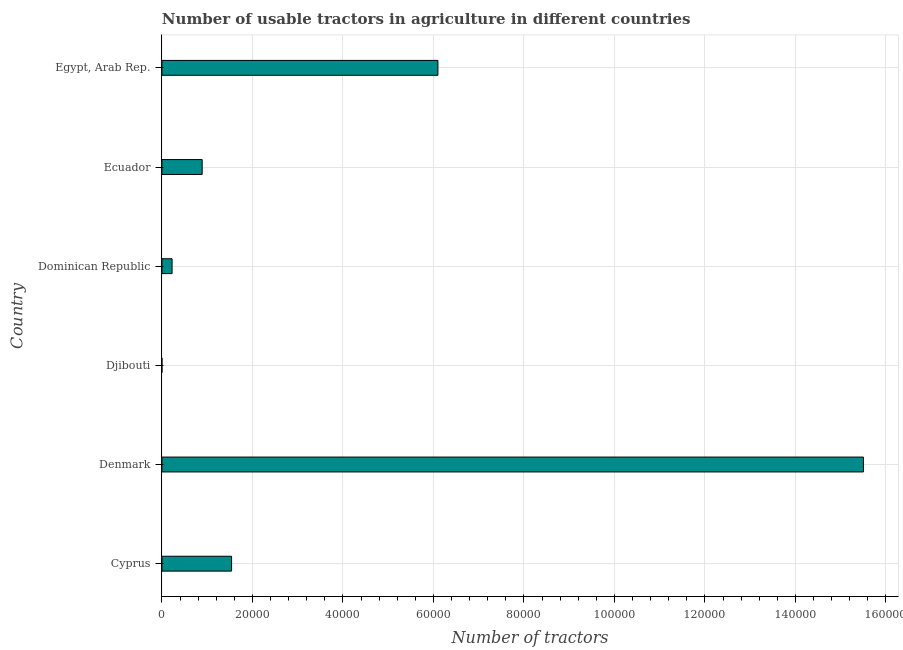What is the title of the graph?
Your answer should be very brief. Number of usable tractors in agriculture in different countries. What is the label or title of the X-axis?
Ensure brevity in your answer.  Number of tractors. What is the number of tractors in Egypt, Arab Rep.?
Keep it short and to the point. 6.10e+04. Across all countries, what is the maximum number of tractors?
Give a very brief answer. 1.55e+05. In which country was the number of tractors maximum?
Give a very brief answer. Denmark. In which country was the number of tractors minimum?
Make the answer very short. Djibouti. What is the sum of the number of tractors?
Provide a short and direct response. 2.43e+05. What is the difference between the number of tractors in Dominican Republic and Ecuador?
Your answer should be very brief. -6650. What is the average number of tractors per country?
Your answer should be compact. 4.04e+04. What is the median number of tractors?
Give a very brief answer. 1.22e+04. What is the ratio of the number of tractors in Denmark to that in Dominican Republic?
Ensure brevity in your answer.  68.9. What is the difference between the highest and the second highest number of tractors?
Make the answer very short. 9.40e+04. What is the difference between the highest and the lowest number of tractors?
Provide a succinct answer. 1.55e+05. How many bars are there?
Your response must be concise. 6. Are all the bars in the graph horizontal?
Offer a very short reply. Yes. What is the Number of tractors of Cyprus?
Your answer should be very brief. 1.54e+04. What is the Number of tractors in Denmark?
Provide a short and direct response. 1.55e+05. What is the Number of tractors in Dominican Republic?
Provide a succinct answer. 2250. What is the Number of tractors in Ecuador?
Make the answer very short. 8900. What is the Number of tractors in Egypt, Arab Rep.?
Provide a short and direct response. 6.10e+04. What is the difference between the Number of tractors in Cyprus and Denmark?
Keep it short and to the point. -1.40e+05. What is the difference between the Number of tractors in Cyprus and Djibouti?
Provide a short and direct response. 1.54e+04. What is the difference between the Number of tractors in Cyprus and Dominican Republic?
Ensure brevity in your answer.  1.32e+04. What is the difference between the Number of tractors in Cyprus and Ecuador?
Provide a succinct answer. 6500. What is the difference between the Number of tractors in Cyprus and Egypt, Arab Rep.?
Give a very brief answer. -4.56e+04. What is the difference between the Number of tractors in Denmark and Djibouti?
Ensure brevity in your answer.  1.55e+05. What is the difference between the Number of tractors in Denmark and Dominican Republic?
Give a very brief answer. 1.53e+05. What is the difference between the Number of tractors in Denmark and Ecuador?
Offer a terse response. 1.46e+05. What is the difference between the Number of tractors in Denmark and Egypt, Arab Rep.?
Offer a terse response. 9.40e+04. What is the difference between the Number of tractors in Djibouti and Dominican Republic?
Make the answer very short. -2242. What is the difference between the Number of tractors in Djibouti and Ecuador?
Your answer should be compact. -8892. What is the difference between the Number of tractors in Djibouti and Egypt, Arab Rep.?
Give a very brief answer. -6.10e+04. What is the difference between the Number of tractors in Dominican Republic and Ecuador?
Ensure brevity in your answer.  -6650. What is the difference between the Number of tractors in Dominican Republic and Egypt, Arab Rep.?
Offer a terse response. -5.88e+04. What is the difference between the Number of tractors in Ecuador and Egypt, Arab Rep.?
Your answer should be very brief. -5.21e+04. What is the ratio of the Number of tractors in Cyprus to that in Denmark?
Your response must be concise. 0.1. What is the ratio of the Number of tractors in Cyprus to that in Djibouti?
Ensure brevity in your answer.  1925. What is the ratio of the Number of tractors in Cyprus to that in Dominican Republic?
Your answer should be very brief. 6.84. What is the ratio of the Number of tractors in Cyprus to that in Ecuador?
Make the answer very short. 1.73. What is the ratio of the Number of tractors in Cyprus to that in Egypt, Arab Rep.?
Your response must be concise. 0.25. What is the ratio of the Number of tractors in Denmark to that in Djibouti?
Your response must be concise. 1.94e+04. What is the ratio of the Number of tractors in Denmark to that in Dominican Republic?
Provide a short and direct response. 68.9. What is the ratio of the Number of tractors in Denmark to that in Ecuador?
Ensure brevity in your answer.  17.42. What is the ratio of the Number of tractors in Denmark to that in Egypt, Arab Rep.?
Keep it short and to the point. 2.54. What is the ratio of the Number of tractors in Djibouti to that in Dominican Republic?
Keep it short and to the point. 0. What is the ratio of the Number of tractors in Dominican Republic to that in Ecuador?
Keep it short and to the point. 0.25. What is the ratio of the Number of tractors in Dominican Republic to that in Egypt, Arab Rep.?
Your response must be concise. 0.04. What is the ratio of the Number of tractors in Ecuador to that in Egypt, Arab Rep.?
Offer a terse response. 0.15. 